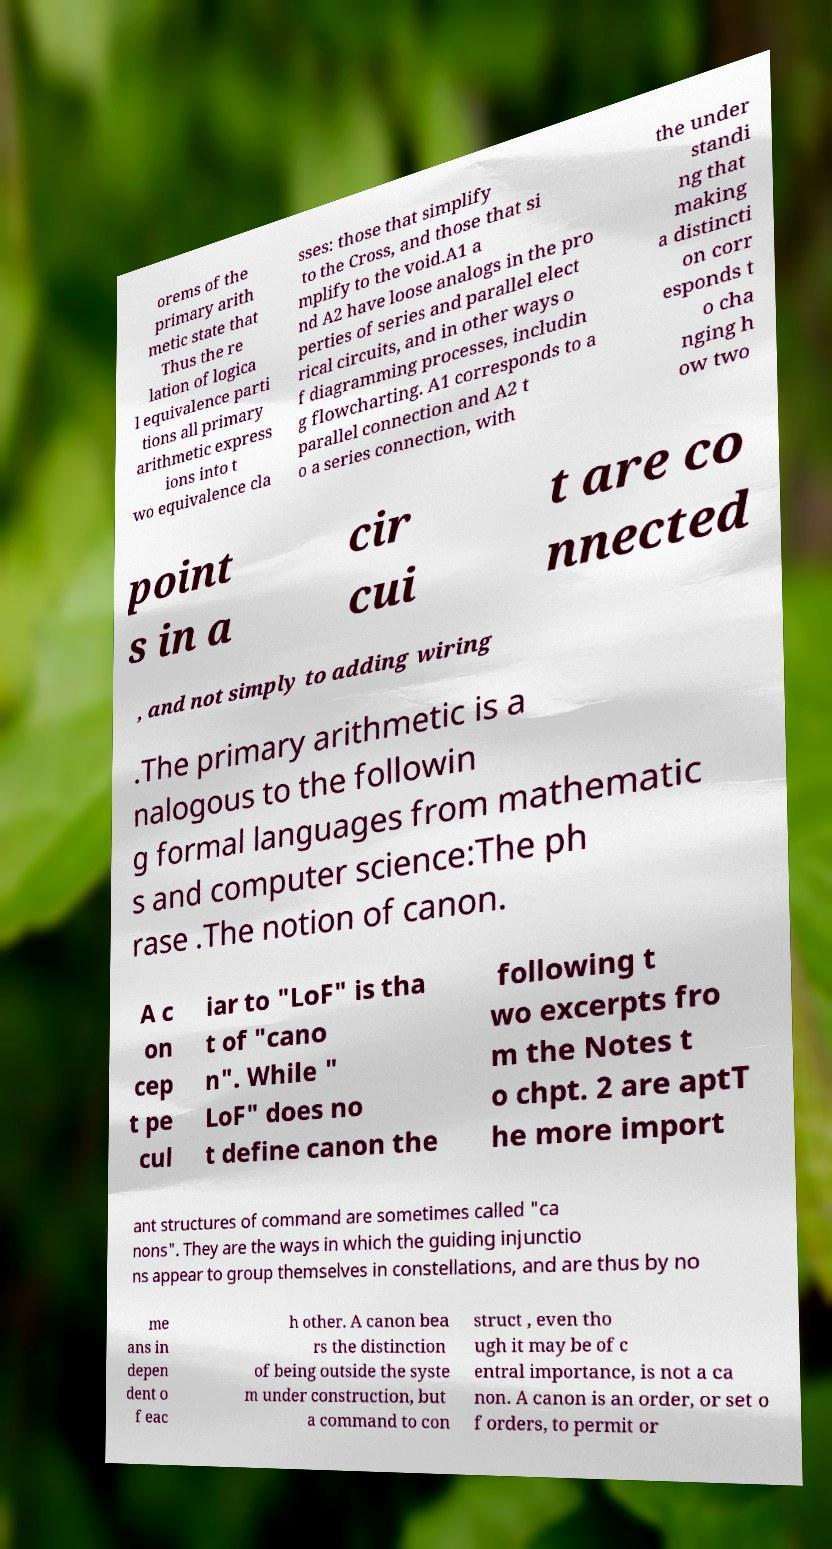What messages or text are displayed in this image? I need them in a readable, typed format. orems of the primary arith metic state that Thus the re lation of logica l equivalence parti tions all primary arithmetic express ions into t wo equivalence cla sses: those that simplify to the Cross, and those that si mplify to the void.A1 a nd A2 have loose analogs in the pro perties of series and parallel elect rical circuits, and in other ways o f diagramming processes, includin g flowcharting. A1 corresponds to a parallel connection and A2 t o a series connection, with the under standi ng that making a distincti on corr esponds t o cha nging h ow two point s in a cir cui t are co nnected , and not simply to adding wiring .The primary arithmetic is a nalogous to the followin g formal languages from mathematic s and computer science:The ph rase .The notion of canon. A c on cep t pe cul iar to "LoF" is tha t of "cano n". While " LoF" does no t define canon the following t wo excerpts fro m the Notes t o chpt. 2 are aptT he more import ant structures of command are sometimes called "ca nons". They are the ways in which the guiding injunctio ns appear to group themselves in constellations, and are thus by no me ans in depen dent o f eac h other. A canon bea rs the distinction of being outside the syste m under construction, but a command to con struct , even tho ugh it may be of c entral importance, is not a ca non. A canon is an order, or set o f orders, to permit or 